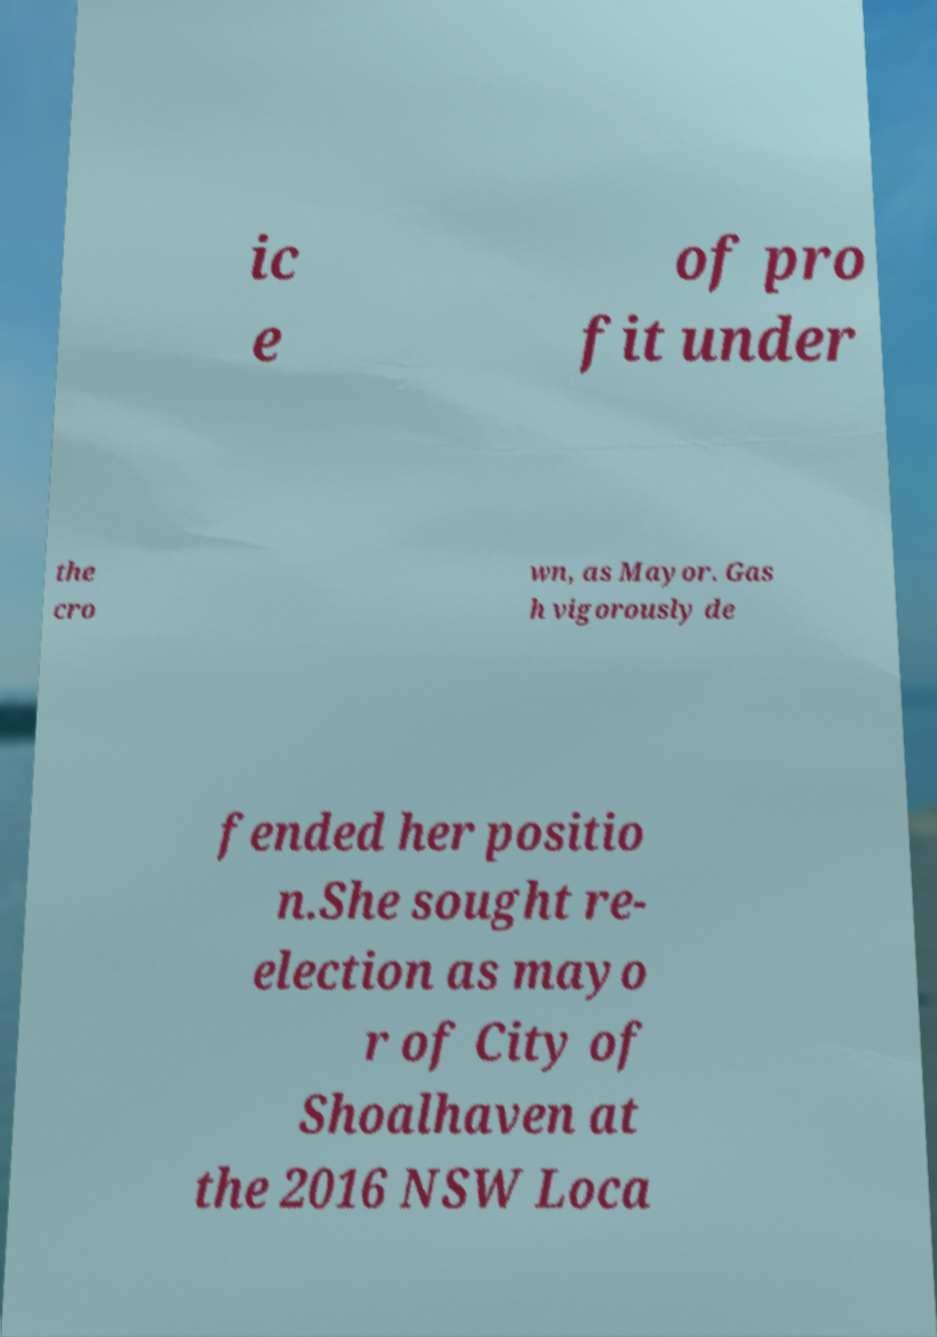Can you read and provide the text displayed in the image?This photo seems to have some interesting text. Can you extract and type it out for me? ic e of pro fit under the cro wn, as Mayor. Gas h vigorously de fended her positio n.She sought re- election as mayo r of City of Shoalhaven at the 2016 NSW Loca 